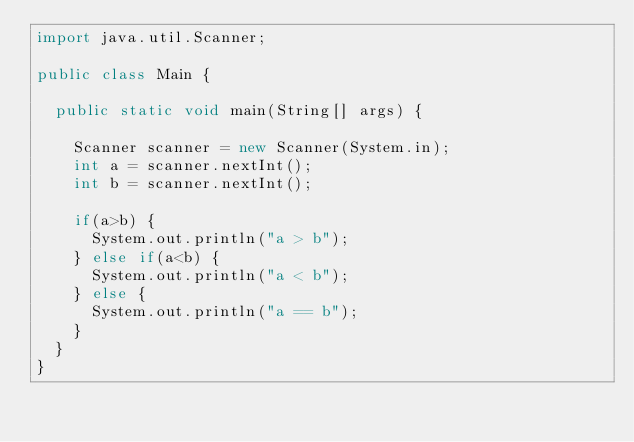Convert code to text. <code><loc_0><loc_0><loc_500><loc_500><_Java_>import java.util.Scanner;

public class Main {

	public static void main(String[] args) {

		Scanner scanner = new Scanner(System.in);
		int a = scanner.nextInt();
		int b = scanner.nextInt();

		if(a>b) {
			System.out.println("a > b");
		} else if(a<b) {
			System.out.println("a < b");
		} else {
			System.out.println("a == b");
		}
	}
}</code> 